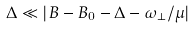<formula> <loc_0><loc_0><loc_500><loc_500>\Delta \ll | B - B _ { 0 } - \Delta - \omega _ { \perp } / \mu |</formula> 